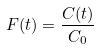<formula> <loc_0><loc_0><loc_500><loc_500>F ( t ) = \frac { C ( t ) } { C _ { 0 } }</formula> 